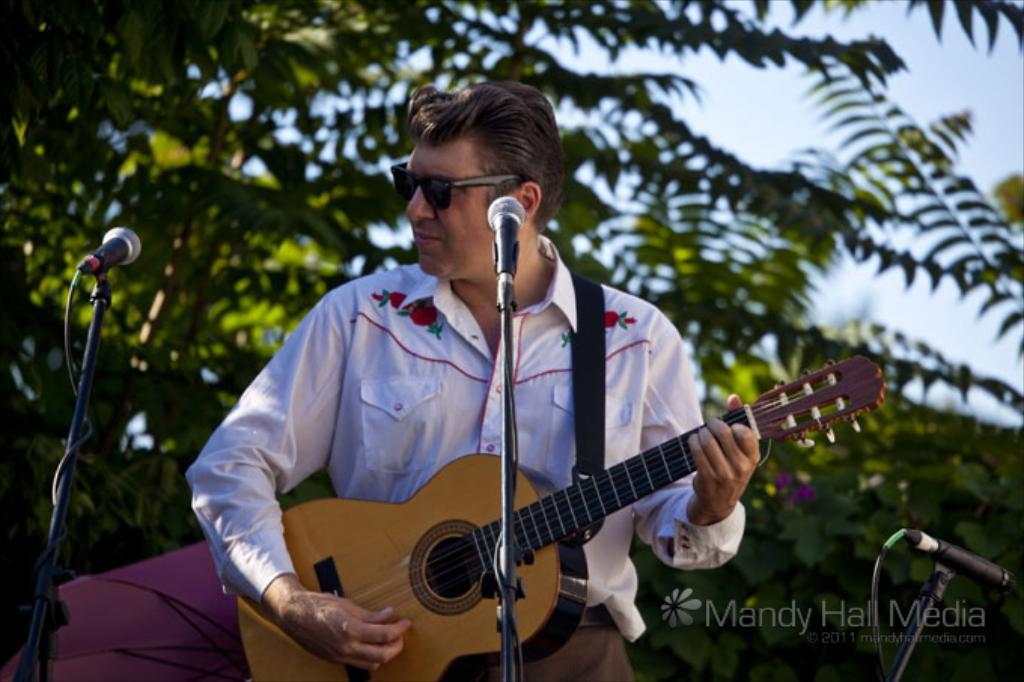What is the man in the image doing? The man is playing a guitar in the image. What object is the man standing in front of? The man is in front of a microphone. What can be seen behind the man in the image? There are trees visible behind the man. What type of insect can be seen crawling on the advertisement in the image? There is no advertisement present in the image, and therefore no insect can be seen crawling on it. 